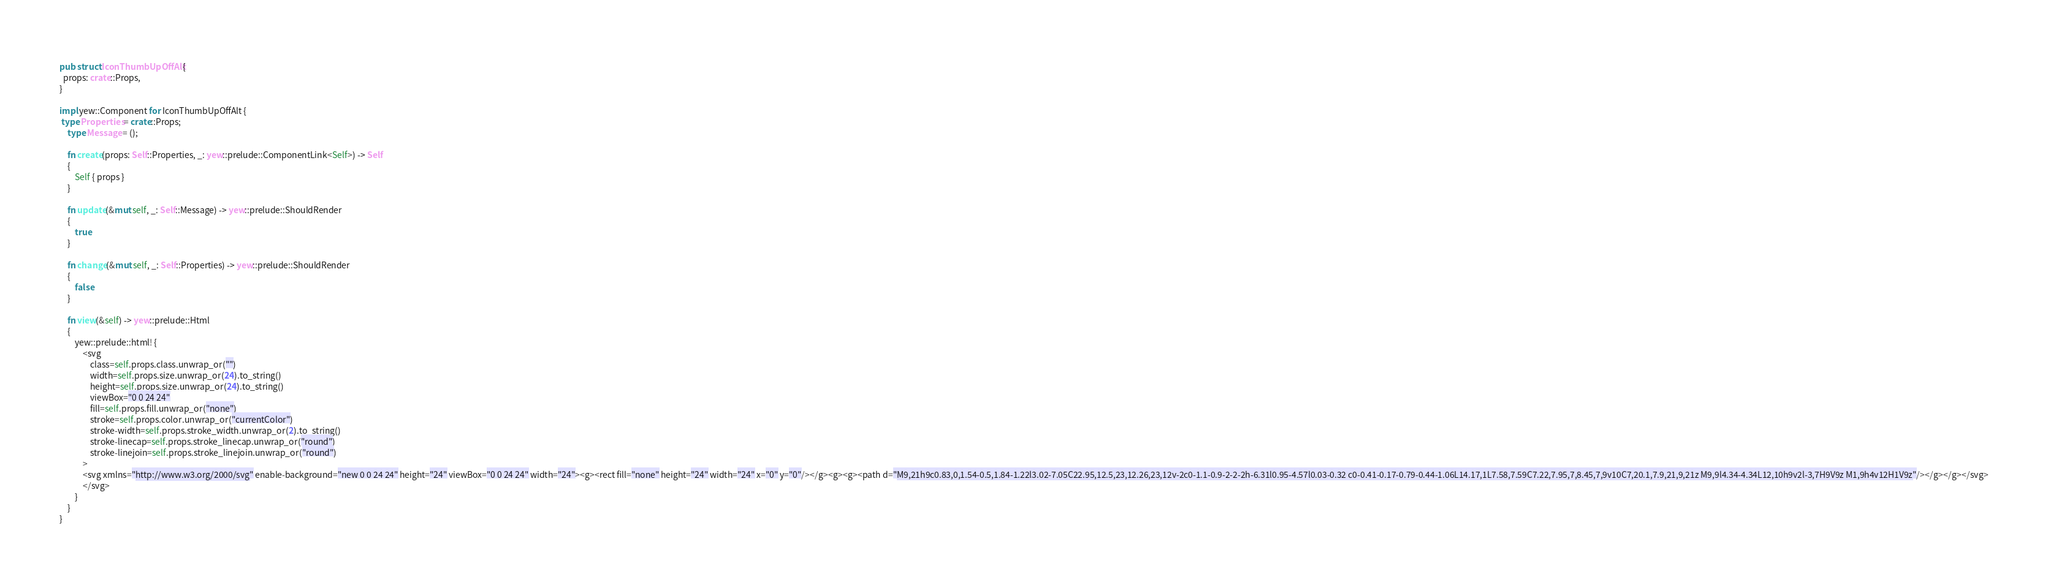Convert code to text. <code><loc_0><loc_0><loc_500><loc_500><_Rust_>
pub struct IconThumbUpOffAlt {
  props: crate::Props,
}

impl yew::Component for IconThumbUpOffAlt {
 type Properties = crate::Props;
    type Message = ();

    fn create(props: Self::Properties, _: yew::prelude::ComponentLink<Self>) -> Self
    {
        Self { props }
    }

    fn update(&mut self, _: Self::Message) -> yew::prelude::ShouldRender
    {
        true
    }

    fn change(&mut self, _: Self::Properties) -> yew::prelude::ShouldRender
    {
        false
    }

    fn view(&self) -> yew::prelude::Html
    {
        yew::prelude::html! {
            <svg
                class=self.props.class.unwrap_or("")
                width=self.props.size.unwrap_or(24).to_string()
                height=self.props.size.unwrap_or(24).to_string()
                viewBox="0 0 24 24"
                fill=self.props.fill.unwrap_or("none")
                stroke=self.props.color.unwrap_or("currentColor")
                stroke-width=self.props.stroke_width.unwrap_or(2).to_string()
                stroke-linecap=self.props.stroke_linecap.unwrap_or("round")
                stroke-linejoin=self.props.stroke_linejoin.unwrap_or("round")
            >
            <svg xmlns="http://www.w3.org/2000/svg" enable-background="new 0 0 24 24" height="24" viewBox="0 0 24 24" width="24"><g><rect fill="none" height="24" width="24" x="0" y="0"/></g><g><g><path d="M9,21h9c0.83,0,1.54-0.5,1.84-1.22l3.02-7.05C22.95,12.5,23,12.26,23,12v-2c0-1.1-0.9-2-2-2h-6.31l0.95-4.57l0.03-0.32 c0-0.41-0.17-0.79-0.44-1.06L14.17,1L7.58,7.59C7.22,7.95,7,8.45,7,9v10C7,20.1,7.9,21,9,21z M9,9l4.34-4.34L12,10h9v2l-3,7H9V9z M1,9h4v12H1V9z"/></g></g></svg>
            </svg>
        }
    }
}


</code> 